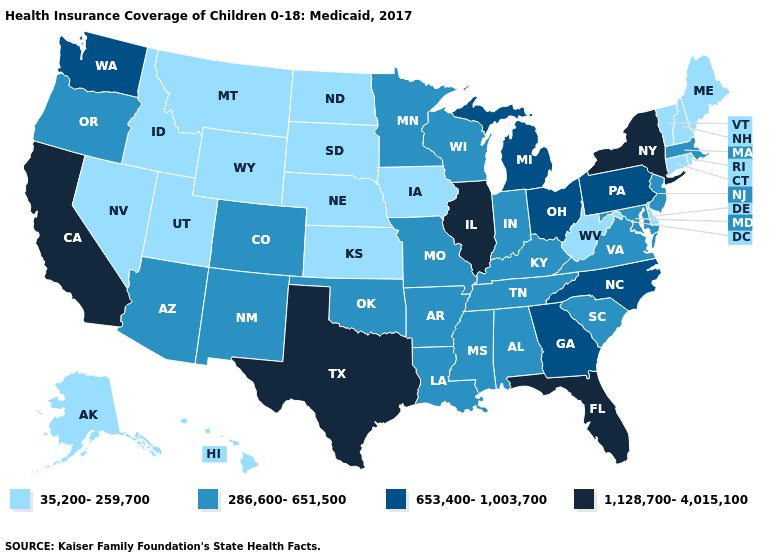Does Texas have the highest value in the USA?
Give a very brief answer. Yes. Does Alaska have the lowest value in the USA?
Short answer required. Yes. Does the first symbol in the legend represent the smallest category?
Keep it brief. Yes. What is the value of New Jersey?
Concise answer only. 286,600-651,500. Name the states that have a value in the range 286,600-651,500?
Concise answer only. Alabama, Arizona, Arkansas, Colorado, Indiana, Kentucky, Louisiana, Maryland, Massachusetts, Minnesota, Mississippi, Missouri, New Jersey, New Mexico, Oklahoma, Oregon, South Carolina, Tennessee, Virginia, Wisconsin. Among the states that border Louisiana , which have the lowest value?
Keep it brief. Arkansas, Mississippi. What is the value of Mississippi?
Be succinct. 286,600-651,500. Name the states that have a value in the range 653,400-1,003,700?
Answer briefly. Georgia, Michigan, North Carolina, Ohio, Pennsylvania, Washington. What is the value of Nevada?
Answer briefly. 35,200-259,700. What is the value of North Dakota?
Quick response, please. 35,200-259,700. How many symbols are there in the legend?
Concise answer only. 4. Does the map have missing data?
Be succinct. No. Among the states that border Nevada , which have the lowest value?
Quick response, please. Idaho, Utah. Among the states that border Wisconsin , does Iowa have the lowest value?
Short answer required. Yes. What is the value of New Mexico?
Keep it brief. 286,600-651,500. 